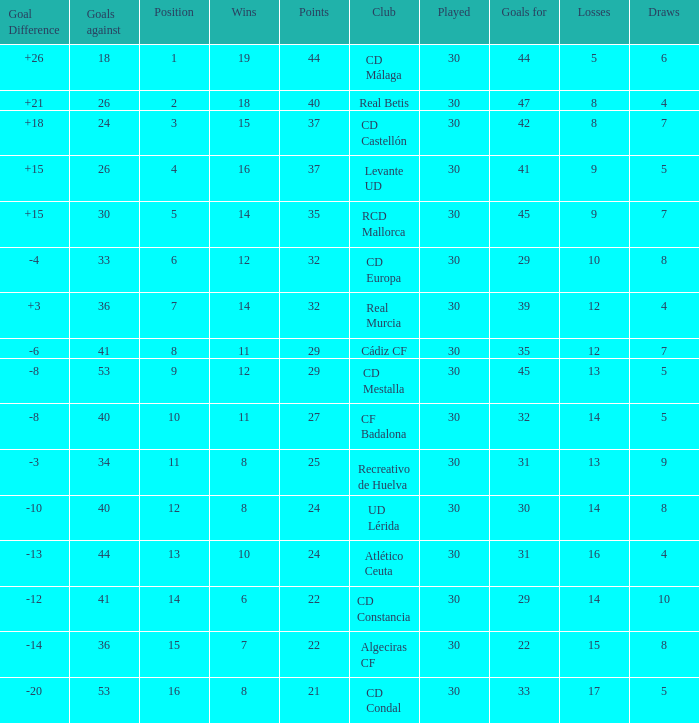What is the number of draws when played is smaller than 30? 0.0. 